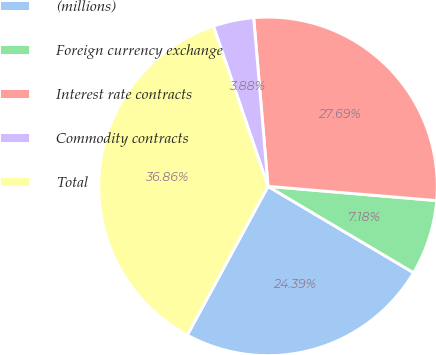Convert chart to OTSL. <chart><loc_0><loc_0><loc_500><loc_500><pie_chart><fcel>(millions)<fcel>Foreign currency exchange<fcel>Interest rate contracts<fcel>Commodity contracts<fcel>Total<nl><fcel>24.39%<fcel>7.18%<fcel>27.69%<fcel>3.88%<fcel>36.86%<nl></chart> 